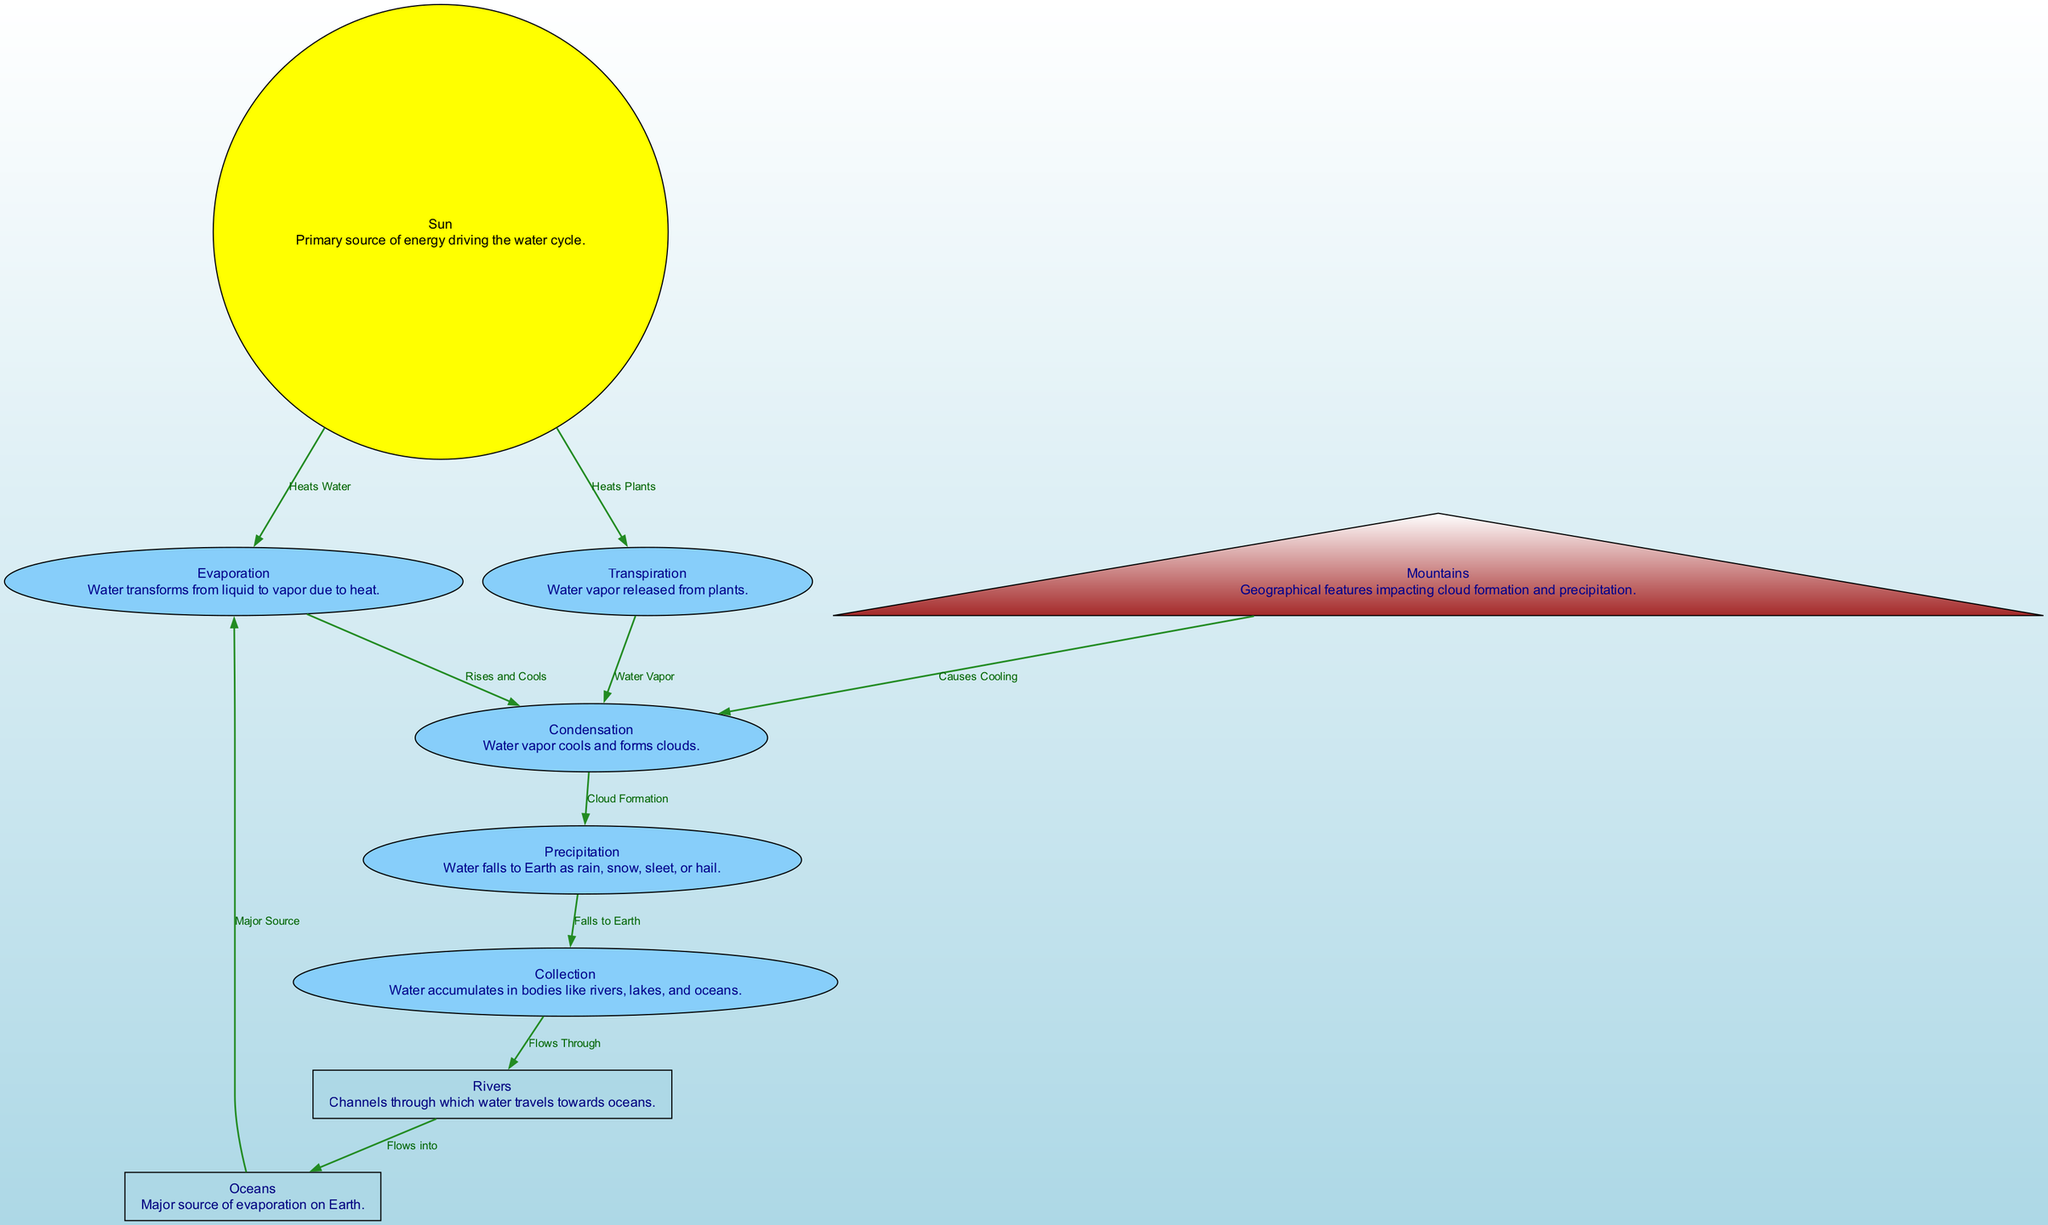What is the final step in the water cycle? The final step listed in the diagram is "Collection," which entails the accumulation of water in various bodies like rivers, lakes, and oceans after precipitation occurs.
Answer: Collection How many stages are depicted in the diagram? The diagram shows five stages: evaporation, transpiration, condensation, precipitation, and collection.
Answer: Five What causes cooling and condensation in the water cycle? "Mountains" are depicted as a factor that causes cooling, which subsequently leads to the formation of clouds or condensation.
Answer: Mountains Which element in the diagram represents the primary source of energy? The "Sun" is represented as the primary source of energy, as indicated in the diagram, driving processes like evaporation and transpiration.
Answer: Sun What do rivers flow into according to the diagram? According to the diagram, "Rivers" flow into "Oceans" as part of the water cycle's collection phase.
Answer: Oceans Explain what happens to water vapor during condensation. During condensation, water vapor cools down and transitions into liquid form, forming clouds, as shown in the flow of the diagram from condensation to precipitation.
Answer: Clouds How does evaporation relate to temperature in the diagram? The diagram illustrates that evaporation occurs when water is heated by the "Sun," indicating a direct relationship between temperature and the phase change of water from liquid to vapor.
Answer: Heats Water What are the two processes that contribute to condensation? The processes that contribute to condensation in the diagram are "Evaporation," where water vapor rises and cools, and "Transpiration," where water vapor is released from plants.
Answer: Evaporation and Transpiration What happens after precipitation according to the diagram? After precipitation, water "Falls to Earth" and accumulates in bodies of water, which is referred to as "Collection" in the diagram.
Answer: Falls to Earth 